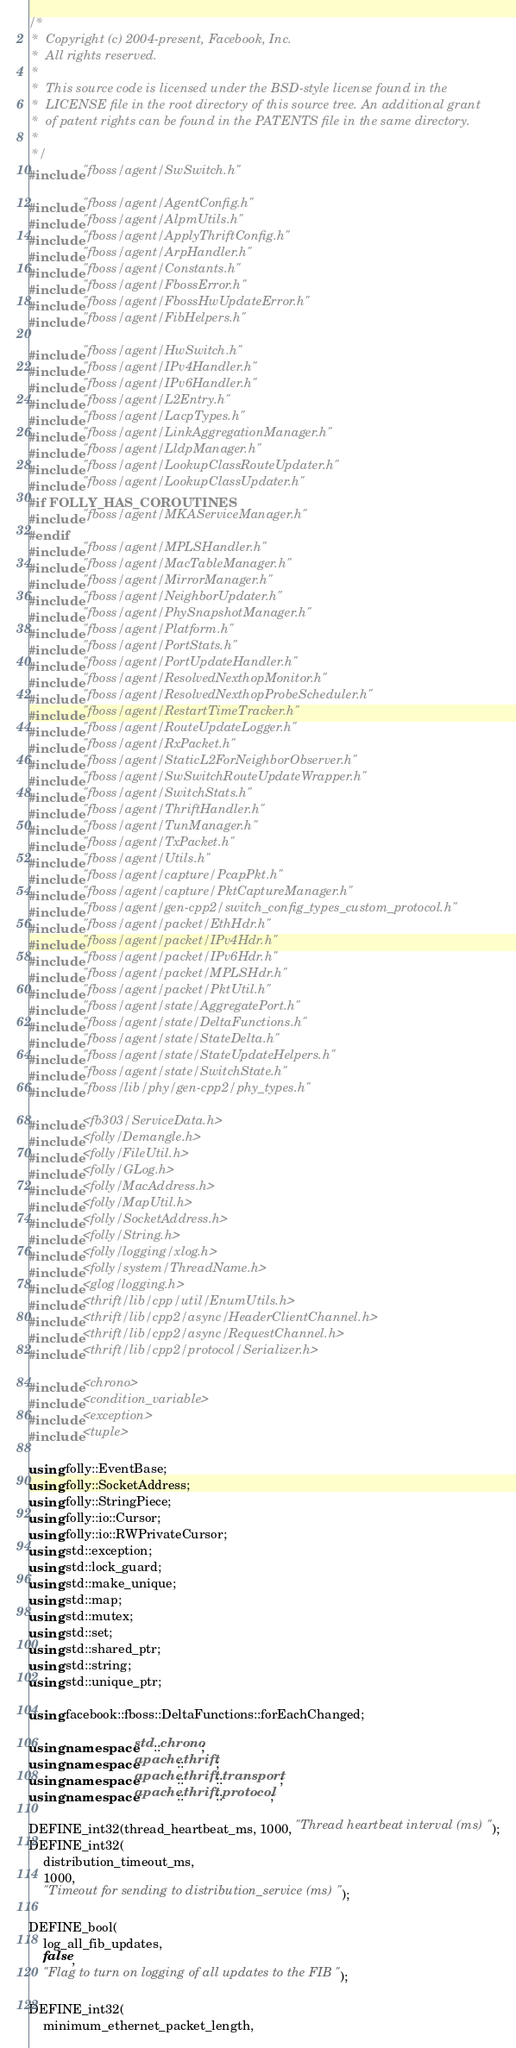Convert code to text. <code><loc_0><loc_0><loc_500><loc_500><_C++_>/*
 *  Copyright (c) 2004-present, Facebook, Inc.
 *  All rights reserved.
 *
 *  This source code is licensed under the BSD-style license found in the
 *  LICENSE file in the root directory of this source tree. An additional grant
 *  of patent rights can be found in the PATENTS file in the same directory.
 *
 */
#include "fboss/agent/SwSwitch.h"

#include "fboss/agent/AgentConfig.h"
#include "fboss/agent/AlpmUtils.h"
#include "fboss/agent/ApplyThriftConfig.h"
#include "fboss/agent/ArpHandler.h"
#include "fboss/agent/Constants.h"
#include "fboss/agent/FbossError.h"
#include "fboss/agent/FbossHwUpdateError.h"
#include "fboss/agent/FibHelpers.h"

#include "fboss/agent/HwSwitch.h"
#include "fboss/agent/IPv4Handler.h"
#include "fboss/agent/IPv6Handler.h"
#include "fboss/agent/L2Entry.h"
#include "fboss/agent/LacpTypes.h"
#include "fboss/agent/LinkAggregationManager.h"
#include "fboss/agent/LldpManager.h"
#include "fboss/agent/LookupClassRouteUpdater.h"
#include "fboss/agent/LookupClassUpdater.h"
#if FOLLY_HAS_COROUTINES
#include "fboss/agent/MKAServiceManager.h"
#endif
#include "fboss/agent/MPLSHandler.h"
#include "fboss/agent/MacTableManager.h"
#include "fboss/agent/MirrorManager.h"
#include "fboss/agent/NeighborUpdater.h"
#include "fboss/agent/PhySnapshotManager.h"
#include "fboss/agent/Platform.h"
#include "fboss/agent/PortStats.h"
#include "fboss/agent/PortUpdateHandler.h"
#include "fboss/agent/ResolvedNexthopMonitor.h"
#include "fboss/agent/ResolvedNexthopProbeScheduler.h"
#include "fboss/agent/RestartTimeTracker.h"
#include "fboss/agent/RouteUpdateLogger.h"
#include "fboss/agent/RxPacket.h"
#include "fboss/agent/StaticL2ForNeighborObserver.h"
#include "fboss/agent/SwSwitchRouteUpdateWrapper.h"
#include "fboss/agent/SwitchStats.h"
#include "fboss/agent/ThriftHandler.h"
#include "fboss/agent/TunManager.h"
#include "fboss/agent/TxPacket.h"
#include "fboss/agent/Utils.h"
#include "fboss/agent/capture/PcapPkt.h"
#include "fboss/agent/capture/PktCaptureManager.h"
#include "fboss/agent/gen-cpp2/switch_config_types_custom_protocol.h"
#include "fboss/agent/packet/EthHdr.h"
#include "fboss/agent/packet/IPv4Hdr.h"
#include "fboss/agent/packet/IPv6Hdr.h"
#include "fboss/agent/packet/MPLSHdr.h"
#include "fboss/agent/packet/PktUtil.h"
#include "fboss/agent/state/AggregatePort.h"
#include "fboss/agent/state/DeltaFunctions.h"
#include "fboss/agent/state/StateDelta.h"
#include "fboss/agent/state/StateUpdateHelpers.h"
#include "fboss/agent/state/SwitchState.h"
#include "fboss/lib/phy/gen-cpp2/phy_types.h"

#include <fb303/ServiceData.h>
#include <folly/Demangle.h>
#include <folly/FileUtil.h>
#include <folly/GLog.h>
#include <folly/MacAddress.h>
#include <folly/MapUtil.h>
#include <folly/SocketAddress.h>
#include <folly/String.h>
#include <folly/logging/xlog.h>
#include <folly/system/ThreadName.h>
#include <glog/logging.h>
#include <thrift/lib/cpp/util/EnumUtils.h>
#include <thrift/lib/cpp2/async/HeaderClientChannel.h>
#include <thrift/lib/cpp2/async/RequestChannel.h>
#include <thrift/lib/cpp2/protocol/Serializer.h>

#include <chrono>
#include <condition_variable>
#include <exception>
#include <tuple>

using folly::EventBase;
using folly::SocketAddress;
using folly::StringPiece;
using folly::io::Cursor;
using folly::io::RWPrivateCursor;
using std::exception;
using std::lock_guard;
using std::make_unique;
using std::map;
using std::mutex;
using std::set;
using std::shared_ptr;
using std::string;
using std::unique_ptr;

using facebook::fboss::DeltaFunctions::forEachChanged;

using namespace std::chrono;
using namespace apache::thrift;
using namespace apache::thrift::transport;
using namespace apache::thrift::protocol;

DEFINE_int32(thread_heartbeat_ms, 1000, "Thread heartbeat interval (ms)");
DEFINE_int32(
    distribution_timeout_ms,
    1000,
    "Timeout for sending to distribution_service (ms)");

DEFINE_bool(
    log_all_fib_updates,
    false,
    "Flag to turn on logging of all updates to the FIB");

DEFINE_int32(
    minimum_ethernet_packet_length,</code> 